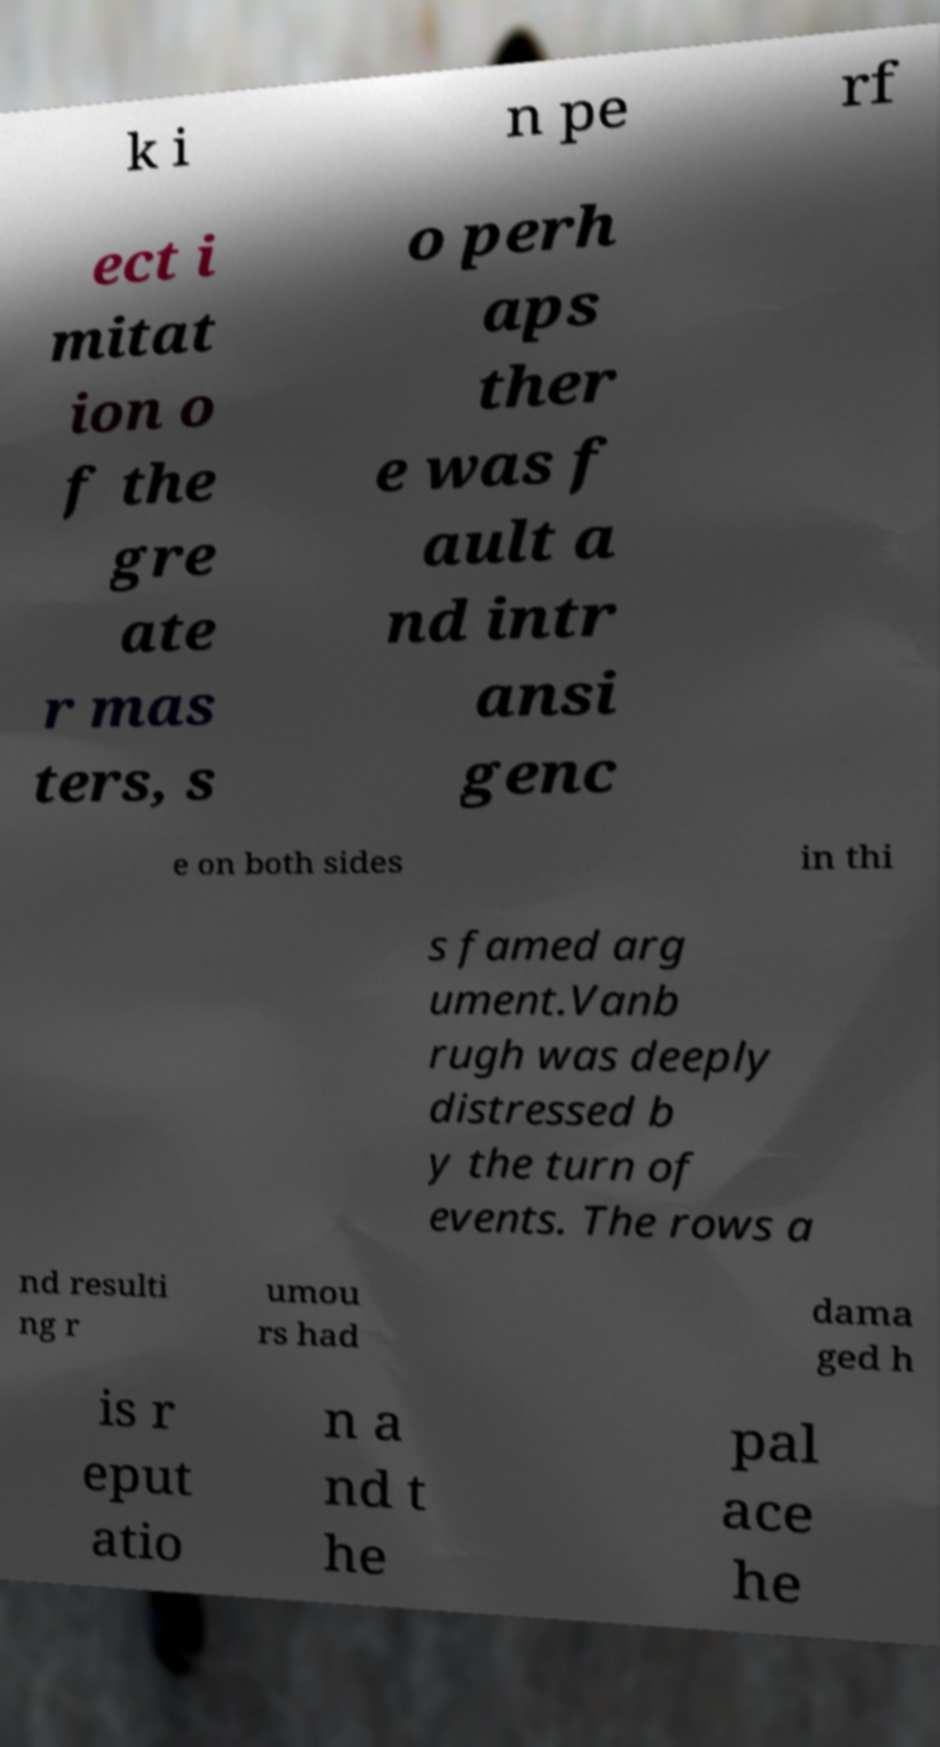What messages or text are displayed in this image? I need them in a readable, typed format. k i n pe rf ect i mitat ion o f the gre ate r mas ters, s o perh aps ther e was f ault a nd intr ansi genc e on both sides in thi s famed arg ument.Vanb rugh was deeply distressed b y the turn of events. The rows a nd resulti ng r umou rs had dama ged h is r eput atio n a nd t he pal ace he 